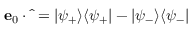<formula> <loc_0><loc_0><loc_500><loc_500>e _ { 0 } \cdot \hat { \sigma } = | \psi _ { + } \rangle \langle \psi _ { + } | - | \psi _ { - } \rangle \langle \psi _ { - } |</formula> 